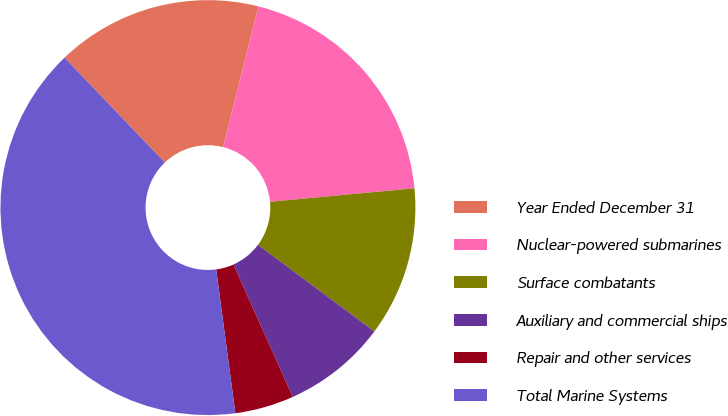Convert chart to OTSL. <chart><loc_0><loc_0><loc_500><loc_500><pie_chart><fcel>Year Ended December 31<fcel>Nuclear-powered submarines<fcel>Surface combatants<fcel>Auxiliary and commercial ships<fcel>Repair and other services<fcel>Total Marine Systems<nl><fcel>16.06%<fcel>19.6%<fcel>11.66%<fcel>8.12%<fcel>4.59%<fcel>39.96%<nl></chart> 